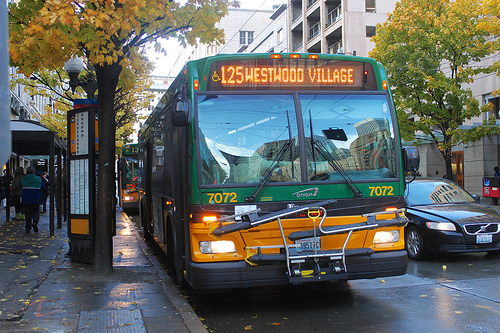Is there a bus on the road near the tree? Yes, there's a bus right next to the sidewalk, closely positioned near a tree along the road, highlighting its accessibility in an urban setting. 